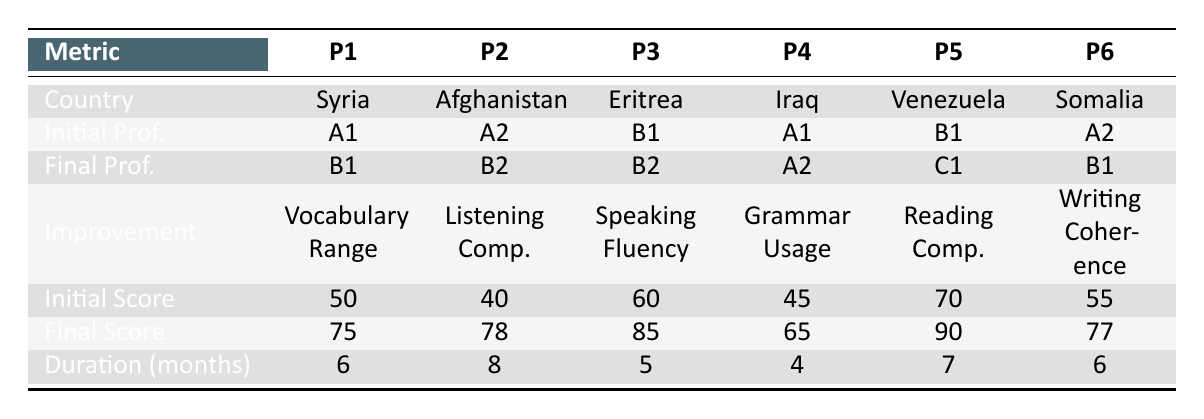What is the final language proficiency level of participant 3? According to the table, the final language proficiency for participant 3 is listed as B2.
Answer: B2 How many months did participant 2 take to improve their listening comprehension? The duration for participant 2 is indicated as 8 months in the table.
Answer: 8 What is the initial score of participant 5 in reading comprehension? The initial score for participant 5, who worked on reading comprehension, is listed as 70 in the table.
Answer: 70 Which participant made the most significant score improvement, and what was their final score? To find the most significant score improvement, we calculate the difference between the initial and final scores for each participant: P1 (25), P2 (38), P3 (25), P4 (20), P5 (20), P6 (22). The highest improvement was by participant 2 with a final score of 78.
Answer: 78 Did all participants improve their language proficiency? All participants started with an initial proficiency level and completed their programs at a higher proficiency level as shown in the initial and final language proficiency columns. Therefore, the answer is yes.
Answer: Yes How much did participant 1's vocabulary range score improve? For participant 1, the initial score was 50 and the final score was 75. The improvement is calculated as 75 - 50 = 25.
Answer: 25 Which participant had the shortest duration of study, and what was their improvement metric? The shortest duration of study is 4 months, which is for participant 4 whose improvement metric is grammar usage.
Answer: Participant 4, Grammar Usage What is the average final score of all participants? To find the average final score, we add all final scores: 75 + 78 + 85 + 65 + 90 + 77 = 470 and divide by 6 participants: 470 / 6 = 78.33.
Answer: 78.33 Which two participants improved from an initial level of A1? From the table, participants 1 and 4 both had an initial proficiency of A1.
Answer: Participants 1 and 4 